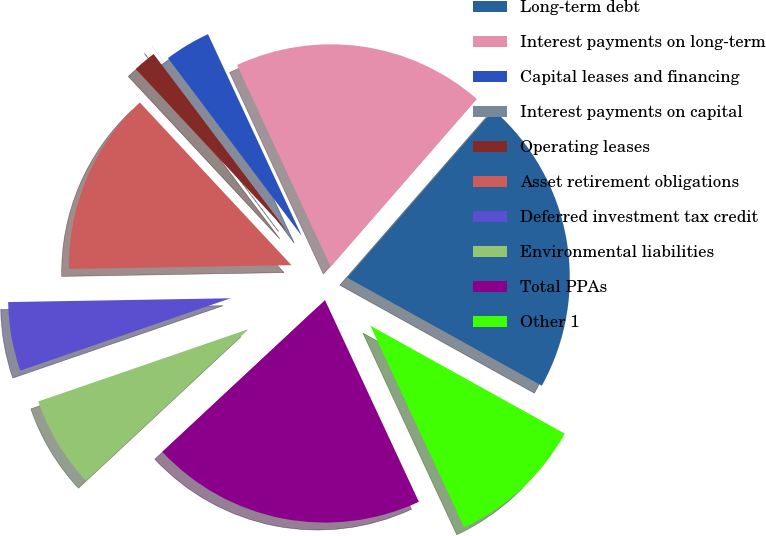<chart> <loc_0><loc_0><loc_500><loc_500><pie_chart><fcel>Long-term debt<fcel>Interest payments on long-term<fcel>Capital leases and financing<fcel>Interest payments on capital<fcel>Operating leases<fcel>Asset retirement obligations<fcel>Deferred investment tax credit<fcel>Environmental liabilities<fcel>Total PPAs<fcel>Other 1<nl><fcel>21.66%<fcel>18.33%<fcel>3.34%<fcel>0.01%<fcel>1.67%<fcel>13.33%<fcel>5.0%<fcel>6.67%<fcel>19.99%<fcel>10.0%<nl></chart> 